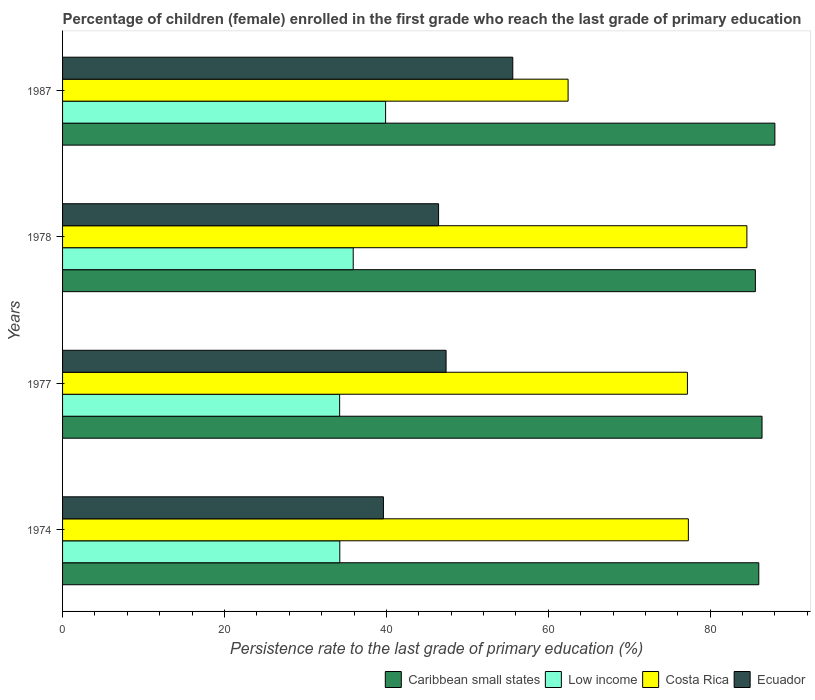How many different coloured bars are there?
Your response must be concise. 4. What is the label of the 2nd group of bars from the top?
Offer a very short reply. 1978. In how many cases, is the number of bars for a given year not equal to the number of legend labels?
Offer a terse response. 0. What is the persistence rate of children in Low income in 1978?
Offer a terse response. 35.9. Across all years, what is the maximum persistence rate of children in Low income?
Make the answer very short. 39.9. Across all years, what is the minimum persistence rate of children in Costa Rica?
Offer a terse response. 62.45. In which year was the persistence rate of children in Caribbean small states maximum?
Your response must be concise. 1987. In which year was the persistence rate of children in Caribbean small states minimum?
Ensure brevity in your answer.  1978. What is the total persistence rate of children in Low income in the graph?
Keep it short and to the point. 144.28. What is the difference between the persistence rate of children in Low income in 1974 and that in 1978?
Offer a terse response. -1.66. What is the difference between the persistence rate of children in Ecuador in 1978 and the persistence rate of children in Caribbean small states in 1974?
Provide a short and direct response. -39.55. What is the average persistence rate of children in Low income per year?
Provide a short and direct response. 36.07. In the year 1977, what is the difference between the persistence rate of children in Caribbean small states and persistence rate of children in Ecuador?
Offer a terse response. 39.03. What is the ratio of the persistence rate of children in Caribbean small states in 1977 to that in 1987?
Offer a very short reply. 0.98. Is the persistence rate of children in Ecuador in 1978 less than that in 1987?
Ensure brevity in your answer.  Yes. Is the difference between the persistence rate of children in Caribbean small states in 1977 and 1987 greater than the difference between the persistence rate of children in Ecuador in 1977 and 1987?
Offer a very short reply. Yes. What is the difference between the highest and the second highest persistence rate of children in Costa Rica?
Your response must be concise. 7.23. What is the difference between the highest and the lowest persistence rate of children in Low income?
Ensure brevity in your answer.  5.68. Is the sum of the persistence rate of children in Costa Rica in 1974 and 1978 greater than the maximum persistence rate of children in Caribbean small states across all years?
Offer a terse response. Yes. What does the 3rd bar from the top in 1978 represents?
Keep it short and to the point. Low income. What does the 1st bar from the bottom in 1978 represents?
Offer a terse response. Caribbean small states. How many bars are there?
Keep it short and to the point. 16. Are the values on the major ticks of X-axis written in scientific E-notation?
Keep it short and to the point. No. Does the graph contain grids?
Your answer should be compact. No. How many legend labels are there?
Provide a succinct answer. 4. How are the legend labels stacked?
Give a very brief answer. Horizontal. What is the title of the graph?
Offer a very short reply. Percentage of children (female) enrolled in the first grade who reach the last grade of primary education. What is the label or title of the X-axis?
Make the answer very short. Persistence rate to the last grade of primary education (%). What is the label or title of the Y-axis?
Keep it short and to the point. Years. What is the Persistence rate to the last grade of primary education (%) in Caribbean small states in 1974?
Provide a short and direct response. 86. What is the Persistence rate to the last grade of primary education (%) in Low income in 1974?
Your response must be concise. 34.25. What is the Persistence rate to the last grade of primary education (%) in Costa Rica in 1974?
Make the answer very short. 77.3. What is the Persistence rate to the last grade of primary education (%) in Ecuador in 1974?
Your answer should be compact. 39.63. What is the Persistence rate to the last grade of primary education (%) of Caribbean small states in 1977?
Give a very brief answer. 86.4. What is the Persistence rate to the last grade of primary education (%) of Low income in 1977?
Make the answer very short. 34.23. What is the Persistence rate to the last grade of primary education (%) of Costa Rica in 1977?
Your answer should be very brief. 77.19. What is the Persistence rate to the last grade of primary education (%) of Ecuador in 1977?
Give a very brief answer. 47.37. What is the Persistence rate to the last grade of primary education (%) of Caribbean small states in 1978?
Ensure brevity in your answer.  85.58. What is the Persistence rate to the last grade of primary education (%) in Low income in 1978?
Give a very brief answer. 35.9. What is the Persistence rate to the last grade of primary education (%) of Costa Rica in 1978?
Offer a very short reply. 84.53. What is the Persistence rate to the last grade of primary education (%) in Ecuador in 1978?
Give a very brief answer. 46.45. What is the Persistence rate to the last grade of primary education (%) of Caribbean small states in 1987?
Provide a short and direct response. 87.99. What is the Persistence rate to the last grade of primary education (%) in Low income in 1987?
Provide a short and direct response. 39.9. What is the Persistence rate to the last grade of primary education (%) in Costa Rica in 1987?
Your answer should be compact. 62.45. What is the Persistence rate to the last grade of primary education (%) of Ecuador in 1987?
Provide a short and direct response. 55.61. Across all years, what is the maximum Persistence rate to the last grade of primary education (%) in Caribbean small states?
Make the answer very short. 87.99. Across all years, what is the maximum Persistence rate to the last grade of primary education (%) of Low income?
Your response must be concise. 39.9. Across all years, what is the maximum Persistence rate to the last grade of primary education (%) in Costa Rica?
Make the answer very short. 84.53. Across all years, what is the maximum Persistence rate to the last grade of primary education (%) in Ecuador?
Keep it short and to the point. 55.61. Across all years, what is the minimum Persistence rate to the last grade of primary education (%) in Caribbean small states?
Keep it short and to the point. 85.58. Across all years, what is the minimum Persistence rate to the last grade of primary education (%) in Low income?
Ensure brevity in your answer.  34.23. Across all years, what is the minimum Persistence rate to the last grade of primary education (%) in Costa Rica?
Your answer should be very brief. 62.45. Across all years, what is the minimum Persistence rate to the last grade of primary education (%) of Ecuador?
Provide a succinct answer. 39.63. What is the total Persistence rate to the last grade of primary education (%) of Caribbean small states in the graph?
Offer a very short reply. 345.97. What is the total Persistence rate to the last grade of primary education (%) of Low income in the graph?
Your response must be concise. 144.28. What is the total Persistence rate to the last grade of primary education (%) of Costa Rica in the graph?
Offer a very short reply. 301.47. What is the total Persistence rate to the last grade of primary education (%) in Ecuador in the graph?
Make the answer very short. 189.07. What is the difference between the Persistence rate to the last grade of primary education (%) of Caribbean small states in 1974 and that in 1977?
Give a very brief answer. -0.4. What is the difference between the Persistence rate to the last grade of primary education (%) in Low income in 1974 and that in 1977?
Ensure brevity in your answer.  0.02. What is the difference between the Persistence rate to the last grade of primary education (%) in Costa Rica in 1974 and that in 1977?
Offer a terse response. 0.11. What is the difference between the Persistence rate to the last grade of primary education (%) in Ecuador in 1974 and that in 1977?
Offer a terse response. -7.74. What is the difference between the Persistence rate to the last grade of primary education (%) of Caribbean small states in 1974 and that in 1978?
Ensure brevity in your answer.  0.42. What is the difference between the Persistence rate to the last grade of primary education (%) in Low income in 1974 and that in 1978?
Make the answer very short. -1.66. What is the difference between the Persistence rate to the last grade of primary education (%) in Costa Rica in 1974 and that in 1978?
Make the answer very short. -7.23. What is the difference between the Persistence rate to the last grade of primary education (%) in Ecuador in 1974 and that in 1978?
Your response must be concise. -6.81. What is the difference between the Persistence rate to the last grade of primary education (%) in Caribbean small states in 1974 and that in 1987?
Make the answer very short. -1.99. What is the difference between the Persistence rate to the last grade of primary education (%) in Low income in 1974 and that in 1987?
Ensure brevity in your answer.  -5.66. What is the difference between the Persistence rate to the last grade of primary education (%) of Costa Rica in 1974 and that in 1987?
Make the answer very short. 14.85. What is the difference between the Persistence rate to the last grade of primary education (%) of Ecuador in 1974 and that in 1987?
Keep it short and to the point. -15.98. What is the difference between the Persistence rate to the last grade of primary education (%) of Caribbean small states in 1977 and that in 1978?
Ensure brevity in your answer.  0.82. What is the difference between the Persistence rate to the last grade of primary education (%) in Low income in 1977 and that in 1978?
Your answer should be very brief. -1.68. What is the difference between the Persistence rate to the last grade of primary education (%) in Costa Rica in 1977 and that in 1978?
Give a very brief answer. -7.34. What is the difference between the Persistence rate to the last grade of primary education (%) of Ecuador in 1977 and that in 1978?
Your answer should be very brief. 0.93. What is the difference between the Persistence rate to the last grade of primary education (%) in Caribbean small states in 1977 and that in 1987?
Your response must be concise. -1.59. What is the difference between the Persistence rate to the last grade of primary education (%) in Low income in 1977 and that in 1987?
Ensure brevity in your answer.  -5.68. What is the difference between the Persistence rate to the last grade of primary education (%) of Costa Rica in 1977 and that in 1987?
Your answer should be compact. 14.74. What is the difference between the Persistence rate to the last grade of primary education (%) in Ecuador in 1977 and that in 1987?
Provide a short and direct response. -8.24. What is the difference between the Persistence rate to the last grade of primary education (%) in Caribbean small states in 1978 and that in 1987?
Make the answer very short. -2.41. What is the difference between the Persistence rate to the last grade of primary education (%) of Low income in 1978 and that in 1987?
Give a very brief answer. -4. What is the difference between the Persistence rate to the last grade of primary education (%) in Costa Rica in 1978 and that in 1987?
Give a very brief answer. 22.09. What is the difference between the Persistence rate to the last grade of primary education (%) of Ecuador in 1978 and that in 1987?
Ensure brevity in your answer.  -9.17. What is the difference between the Persistence rate to the last grade of primary education (%) in Caribbean small states in 1974 and the Persistence rate to the last grade of primary education (%) in Low income in 1977?
Your response must be concise. 51.78. What is the difference between the Persistence rate to the last grade of primary education (%) in Caribbean small states in 1974 and the Persistence rate to the last grade of primary education (%) in Costa Rica in 1977?
Offer a terse response. 8.82. What is the difference between the Persistence rate to the last grade of primary education (%) in Caribbean small states in 1974 and the Persistence rate to the last grade of primary education (%) in Ecuador in 1977?
Your response must be concise. 38.63. What is the difference between the Persistence rate to the last grade of primary education (%) of Low income in 1974 and the Persistence rate to the last grade of primary education (%) of Costa Rica in 1977?
Your answer should be compact. -42.94. What is the difference between the Persistence rate to the last grade of primary education (%) in Low income in 1974 and the Persistence rate to the last grade of primary education (%) in Ecuador in 1977?
Your response must be concise. -13.13. What is the difference between the Persistence rate to the last grade of primary education (%) in Costa Rica in 1974 and the Persistence rate to the last grade of primary education (%) in Ecuador in 1977?
Keep it short and to the point. 29.93. What is the difference between the Persistence rate to the last grade of primary education (%) of Caribbean small states in 1974 and the Persistence rate to the last grade of primary education (%) of Low income in 1978?
Provide a short and direct response. 50.1. What is the difference between the Persistence rate to the last grade of primary education (%) of Caribbean small states in 1974 and the Persistence rate to the last grade of primary education (%) of Costa Rica in 1978?
Your answer should be compact. 1.47. What is the difference between the Persistence rate to the last grade of primary education (%) of Caribbean small states in 1974 and the Persistence rate to the last grade of primary education (%) of Ecuador in 1978?
Offer a terse response. 39.55. What is the difference between the Persistence rate to the last grade of primary education (%) in Low income in 1974 and the Persistence rate to the last grade of primary education (%) in Costa Rica in 1978?
Offer a very short reply. -50.29. What is the difference between the Persistence rate to the last grade of primary education (%) of Low income in 1974 and the Persistence rate to the last grade of primary education (%) of Ecuador in 1978?
Keep it short and to the point. -12.2. What is the difference between the Persistence rate to the last grade of primary education (%) of Costa Rica in 1974 and the Persistence rate to the last grade of primary education (%) of Ecuador in 1978?
Offer a terse response. 30.85. What is the difference between the Persistence rate to the last grade of primary education (%) in Caribbean small states in 1974 and the Persistence rate to the last grade of primary education (%) in Low income in 1987?
Keep it short and to the point. 46.1. What is the difference between the Persistence rate to the last grade of primary education (%) in Caribbean small states in 1974 and the Persistence rate to the last grade of primary education (%) in Costa Rica in 1987?
Your answer should be compact. 23.56. What is the difference between the Persistence rate to the last grade of primary education (%) of Caribbean small states in 1974 and the Persistence rate to the last grade of primary education (%) of Ecuador in 1987?
Provide a short and direct response. 30.39. What is the difference between the Persistence rate to the last grade of primary education (%) of Low income in 1974 and the Persistence rate to the last grade of primary education (%) of Costa Rica in 1987?
Give a very brief answer. -28.2. What is the difference between the Persistence rate to the last grade of primary education (%) of Low income in 1974 and the Persistence rate to the last grade of primary education (%) of Ecuador in 1987?
Keep it short and to the point. -21.37. What is the difference between the Persistence rate to the last grade of primary education (%) in Costa Rica in 1974 and the Persistence rate to the last grade of primary education (%) in Ecuador in 1987?
Offer a very short reply. 21.69. What is the difference between the Persistence rate to the last grade of primary education (%) of Caribbean small states in 1977 and the Persistence rate to the last grade of primary education (%) of Low income in 1978?
Offer a terse response. 50.5. What is the difference between the Persistence rate to the last grade of primary education (%) of Caribbean small states in 1977 and the Persistence rate to the last grade of primary education (%) of Costa Rica in 1978?
Your answer should be very brief. 1.87. What is the difference between the Persistence rate to the last grade of primary education (%) of Caribbean small states in 1977 and the Persistence rate to the last grade of primary education (%) of Ecuador in 1978?
Make the answer very short. 39.95. What is the difference between the Persistence rate to the last grade of primary education (%) in Low income in 1977 and the Persistence rate to the last grade of primary education (%) in Costa Rica in 1978?
Keep it short and to the point. -50.31. What is the difference between the Persistence rate to the last grade of primary education (%) in Low income in 1977 and the Persistence rate to the last grade of primary education (%) in Ecuador in 1978?
Ensure brevity in your answer.  -12.22. What is the difference between the Persistence rate to the last grade of primary education (%) in Costa Rica in 1977 and the Persistence rate to the last grade of primary education (%) in Ecuador in 1978?
Your answer should be very brief. 30.74. What is the difference between the Persistence rate to the last grade of primary education (%) of Caribbean small states in 1977 and the Persistence rate to the last grade of primary education (%) of Low income in 1987?
Your response must be concise. 46.5. What is the difference between the Persistence rate to the last grade of primary education (%) of Caribbean small states in 1977 and the Persistence rate to the last grade of primary education (%) of Costa Rica in 1987?
Give a very brief answer. 23.96. What is the difference between the Persistence rate to the last grade of primary education (%) of Caribbean small states in 1977 and the Persistence rate to the last grade of primary education (%) of Ecuador in 1987?
Your answer should be compact. 30.79. What is the difference between the Persistence rate to the last grade of primary education (%) of Low income in 1977 and the Persistence rate to the last grade of primary education (%) of Costa Rica in 1987?
Make the answer very short. -28.22. What is the difference between the Persistence rate to the last grade of primary education (%) in Low income in 1977 and the Persistence rate to the last grade of primary education (%) in Ecuador in 1987?
Provide a succinct answer. -21.39. What is the difference between the Persistence rate to the last grade of primary education (%) in Costa Rica in 1977 and the Persistence rate to the last grade of primary education (%) in Ecuador in 1987?
Provide a succinct answer. 21.57. What is the difference between the Persistence rate to the last grade of primary education (%) in Caribbean small states in 1978 and the Persistence rate to the last grade of primary education (%) in Low income in 1987?
Your response must be concise. 45.68. What is the difference between the Persistence rate to the last grade of primary education (%) in Caribbean small states in 1978 and the Persistence rate to the last grade of primary education (%) in Costa Rica in 1987?
Your answer should be very brief. 23.13. What is the difference between the Persistence rate to the last grade of primary education (%) in Caribbean small states in 1978 and the Persistence rate to the last grade of primary education (%) in Ecuador in 1987?
Provide a succinct answer. 29.97. What is the difference between the Persistence rate to the last grade of primary education (%) of Low income in 1978 and the Persistence rate to the last grade of primary education (%) of Costa Rica in 1987?
Make the answer very short. -26.54. What is the difference between the Persistence rate to the last grade of primary education (%) of Low income in 1978 and the Persistence rate to the last grade of primary education (%) of Ecuador in 1987?
Your response must be concise. -19.71. What is the difference between the Persistence rate to the last grade of primary education (%) in Costa Rica in 1978 and the Persistence rate to the last grade of primary education (%) in Ecuador in 1987?
Provide a short and direct response. 28.92. What is the average Persistence rate to the last grade of primary education (%) of Caribbean small states per year?
Keep it short and to the point. 86.49. What is the average Persistence rate to the last grade of primary education (%) of Low income per year?
Your answer should be very brief. 36.07. What is the average Persistence rate to the last grade of primary education (%) in Costa Rica per year?
Offer a very short reply. 75.37. What is the average Persistence rate to the last grade of primary education (%) of Ecuador per year?
Ensure brevity in your answer.  47.27. In the year 1974, what is the difference between the Persistence rate to the last grade of primary education (%) in Caribbean small states and Persistence rate to the last grade of primary education (%) in Low income?
Make the answer very short. 51.76. In the year 1974, what is the difference between the Persistence rate to the last grade of primary education (%) in Caribbean small states and Persistence rate to the last grade of primary education (%) in Costa Rica?
Your response must be concise. 8.7. In the year 1974, what is the difference between the Persistence rate to the last grade of primary education (%) in Caribbean small states and Persistence rate to the last grade of primary education (%) in Ecuador?
Ensure brevity in your answer.  46.37. In the year 1974, what is the difference between the Persistence rate to the last grade of primary education (%) of Low income and Persistence rate to the last grade of primary education (%) of Costa Rica?
Offer a very short reply. -43.06. In the year 1974, what is the difference between the Persistence rate to the last grade of primary education (%) of Low income and Persistence rate to the last grade of primary education (%) of Ecuador?
Give a very brief answer. -5.39. In the year 1974, what is the difference between the Persistence rate to the last grade of primary education (%) of Costa Rica and Persistence rate to the last grade of primary education (%) of Ecuador?
Make the answer very short. 37.67. In the year 1977, what is the difference between the Persistence rate to the last grade of primary education (%) of Caribbean small states and Persistence rate to the last grade of primary education (%) of Low income?
Your answer should be compact. 52.18. In the year 1977, what is the difference between the Persistence rate to the last grade of primary education (%) of Caribbean small states and Persistence rate to the last grade of primary education (%) of Costa Rica?
Offer a very short reply. 9.22. In the year 1977, what is the difference between the Persistence rate to the last grade of primary education (%) of Caribbean small states and Persistence rate to the last grade of primary education (%) of Ecuador?
Your answer should be compact. 39.03. In the year 1977, what is the difference between the Persistence rate to the last grade of primary education (%) in Low income and Persistence rate to the last grade of primary education (%) in Costa Rica?
Make the answer very short. -42.96. In the year 1977, what is the difference between the Persistence rate to the last grade of primary education (%) in Low income and Persistence rate to the last grade of primary education (%) in Ecuador?
Ensure brevity in your answer.  -13.15. In the year 1977, what is the difference between the Persistence rate to the last grade of primary education (%) in Costa Rica and Persistence rate to the last grade of primary education (%) in Ecuador?
Offer a very short reply. 29.81. In the year 1978, what is the difference between the Persistence rate to the last grade of primary education (%) of Caribbean small states and Persistence rate to the last grade of primary education (%) of Low income?
Provide a short and direct response. 49.68. In the year 1978, what is the difference between the Persistence rate to the last grade of primary education (%) in Caribbean small states and Persistence rate to the last grade of primary education (%) in Costa Rica?
Your response must be concise. 1.05. In the year 1978, what is the difference between the Persistence rate to the last grade of primary education (%) in Caribbean small states and Persistence rate to the last grade of primary education (%) in Ecuador?
Ensure brevity in your answer.  39.13. In the year 1978, what is the difference between the Persistence rate to the last grade of primary education (%) of Low income and Persistence rate to the last grade of primary education (%) of Costa Rica?
Provide a short and direct response. -48.63. In the year 1978, what is the difference between the Persistence rate to the last grade of primary education (%) in Low income and Persistence rate to the last grade of primary education (%) in Ecuador?
Provide a short and direct response. -10.54. In the year 1978, what is the difference between the Persistence rate to the last grade of primary education (%) of Costa Rica and Persistence rate to the last grade of primary education (%) of Ecuador?
Your response must be concise. 38.08. In the year 1987, what is the difference between the Persistence rate to the last grade of primary education (%) in Caribbean small states and Persistence rate to the last grade of primary education (%) in Low income?
Make the answer very short. 48.09. In the year 1987, what is the difference between the Persistence rate to the last grade of primary education (%) of Caribbean small states and Persistence rate to the last grade of primary education (%) of Costa Rica?
Offer a very short reply. 25.54. In the year 1987, what is the difference between the Persistence rate to the last grade of primary education (%) of Caribbean small states and Persistence rate to the last grade of primary education (%) of Ecuador?
Your answer should be very brief. 32.38. In the year 1987, what is the difference between the Persistence rate to the last grade of primary education (%) of Low income and Persistence rate to the last grade of primary education (%) of Costa Rica?
Your answer should be compact. -22.54. In the year 1987, what is the difference between the Persistence rate to the last grade of primary education (%) in Low income and Persistence rate to the last grade of primary education (%) in Ecuador?
Give a very brief answer. -15.71. In the year 1987, what is the difference between the Persistence rate to the last grade of primary education (%) of Costa Rica and Persistence rate to the last grade of primary education (%) of Ecuador?
Offer a very short reply. 6.83. What is the ratio of the Persistence rate to the last grade of primary education (%) of Low income in 1974 to that in 1977?
Ensure brevity in your answer.  1. What is the ratio of the Persistence rate to the last grade of primary education (%) in Ecuador in 1974 to that in 1977?
Offer a very short reply. 0.84. What is the ratio of the Persistence rate to the last grade of primary education (%) of Low income in 1974 to that in 1978?
Give a very brief answer. 0.95. What is the ratio of the Persistence rate to the last grade of primary education (%) in Costa Rica in 1974 to that in 1978?
Your answer should be compact. 0.91. What is the ratio of the Persistence rate to the last grade of primary education (%) of Ecuador in 1974 to that in 1978?
Your answer should be very brief. 0.85. What is the ratio of the Persistence rate to the last grade of primary education (%) of Caribbean small states in 1974 to that in 1987?
Make the answer very short. 0.98. What is the ratio of the Persistence rate to the last grade of primary education (%) of Low income in 1974 to that in 1987?
Your answer should be compact. 0.86. What is the ratio of the Persistence rate to the last grade of primary education (%) in Costa Rica in 1974 to that in 1987?
Your answer should be very brief. 1.24. What is the ratio of the Persistence rate to the last grade of primary education (%) in Ecuador in 1974 to that in 1987?
Ensure brevity in your answer.  0.71. What is the ratio of the Persistence rate to the last grade of primary education (%) of Caribbean small states in 1977 to that in 1978?
Keep it short and to the point. 1.01. What is the ratio of the Persistence rate to the last grade of primary education (%) of Low income in 1977 to that in 1978?
Provide a succinct answer. 0.95. What is the ratio of the Persistence rate to the last grade of primary education (%) in Costa Rica in 1977 to that in 1978?
Your response must be concise. 0.91. What is the ratio of the Persistence rate to the last grade of primary education (%) in Ecuador in 1977 to that in 1978?
Give a very brief answer. 1.02. What is the ratio of the Persistence rate to the last grade of primary education (%) of Caribbean small states in 1977 to that in 1987?
Your answer should be compact. 0.98. What is the ratio of the Persistence rate to the last grade of primary education (%) of Low income in 1977 to that in 1987?
Keep it short and to the point. 0.86. What is the ratio of the Persistence rate to the last grade of primary education (%) in Costa Rica in 1977 to that in 1987?
Offer a terse response. 1.24. What is the ratio of the Persistence rate to the last grade of primary education (%) of Ecuador in 1977 to that in 1987?
Offer a terse response. 0.85. What is the ratio of the Persistence rate to the last grade of primary education (%) in Caribbean small states in 1978 to that in 1987?
Offer a terse response. 0.97. What is the ratio of the Persistence rate to the last grade of primary education (%) of Low income in 1978 to that in 1987?
Offer a terse response. 0.9. What is the ratio of the Persistence rate to the last grade of primary education (%) of Costa Rica in 1978 to that in 1987?
Your answer should be very brief. 1.35. What is the ratio of the Persistence rate to the last grade of primary education (%) in Ecuador in 1978 to that in 1987?
Ensure brevity in your answer.  0.84. What is the difference between the highest and the second highest Persistence rate to the last grade of primary education (%) of Caribbean small states?
Provide a short and direct response. 1.59. What is the difference between the highest and the second highest Persistence rate to the last grade of primary education (%) in Low income?
Your answer should be very brief. 4. What is the difference between the highest and the second highest Persistence rate to the last grade of primary education (%) in Costa Rica?
Keep it short and to the point. 7.23. What is the difference between the highest and the second highest Persistence rate to the last grade of primary education (%) in Ecuador?
Make the answer very short. 8.24. What is the difference between the highest and the lowest Persistence rate to the last grade of primary education (%) of Caribbean small states?
Your answer should be compact. 2.41. What is the difference between the highest and the lowest Persistence rate to the last grade of primary education (%) of Low income?
Offer a terse response. 5.68. What is the difference between the highest and the lowest Persistence rate to the last grade of primary education (%) of Costa Rica?
Offer a very short reply. 22.09. What is the difference between the highest and the lowest Persistence rate to the last grade of primary education (%) in Ecuador?
Make the answer very short. 15.98. 